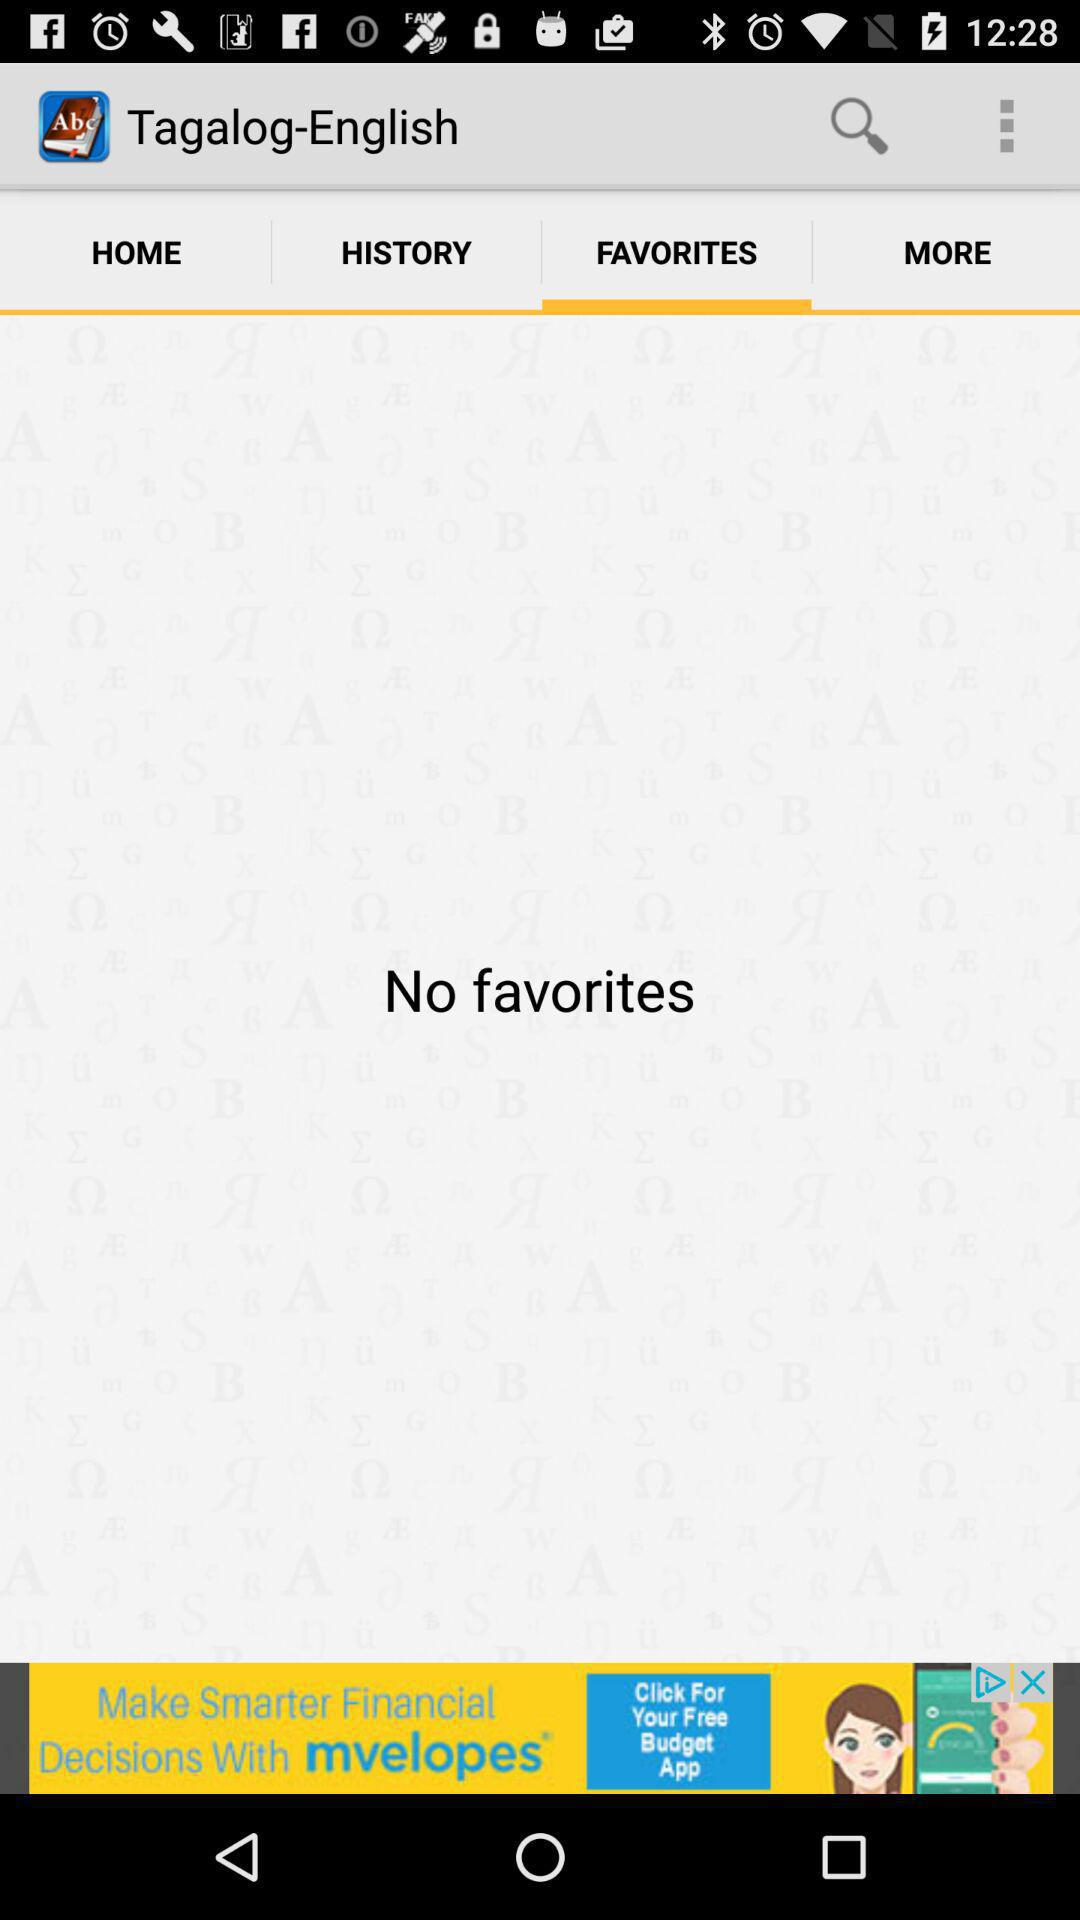Are there any favorites? There are no favorites. 